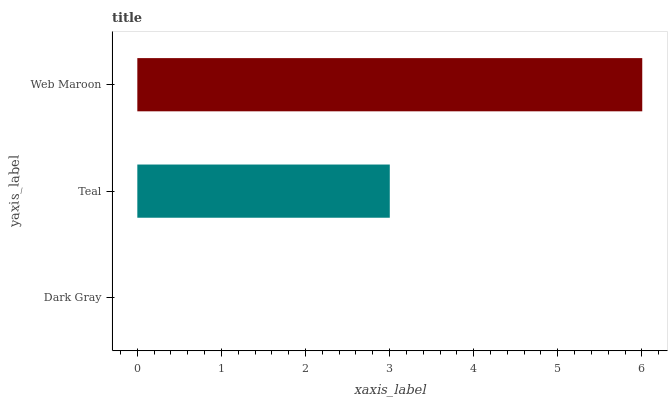Is Dark Gray the minimum?
Answer yes or no. Yes. Is Web Maroon the maximum?
Answer yes or no. Yes. Is Teal the minimum?
Answer yes or no. No. Is Teal the maximum?
Answer yes or no. No. Is Teal greater than Dark Gray?
Answer yes or no. Yes. Is Dark Gray less than Teal?
Answer yes or no. Yes. Is Dark Gray greater than Teal?
Answer yes or no. No. Is Teal less than Dark Gray?
Answer yes or no. No. Is Teal the high median?
Answer yes or no. Yes. Is Teal the low median?
Answer yes or no. Yes. Is Web Maroon the high median?
Answer yes or no. No. Is Web Maroon the low median?
Answer yes or no. No. 